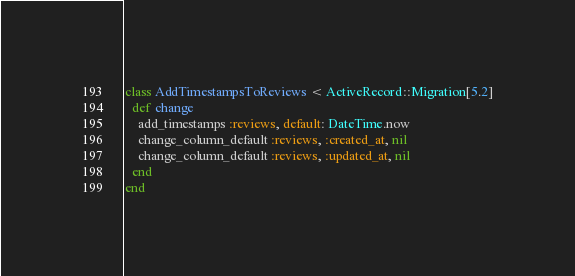<code> <loc_0><loc_0><loc_500><loc_500><_Ruby_>class AddTimestampsToReviews < ActiveRecord::Migration[5.2]
  def change
    add_timestamps :reviews, default: DateTime.now
    change_column_default :reviews, :created_at, nil
    change_column_default :reviews, :updated_at, nil
  end
end
</code> 